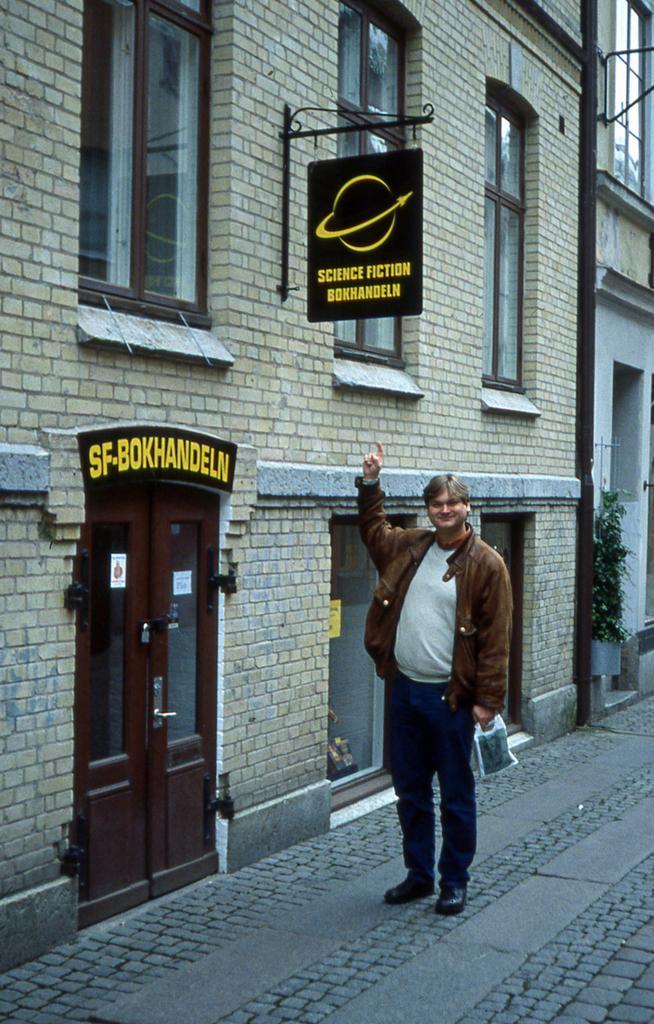In one or two sentences, can you explain what this image depicts? In the foreground I can see a person is standing on the road in front of a building, windows, board, door and a houseplant. This image is taken may be on the road. 